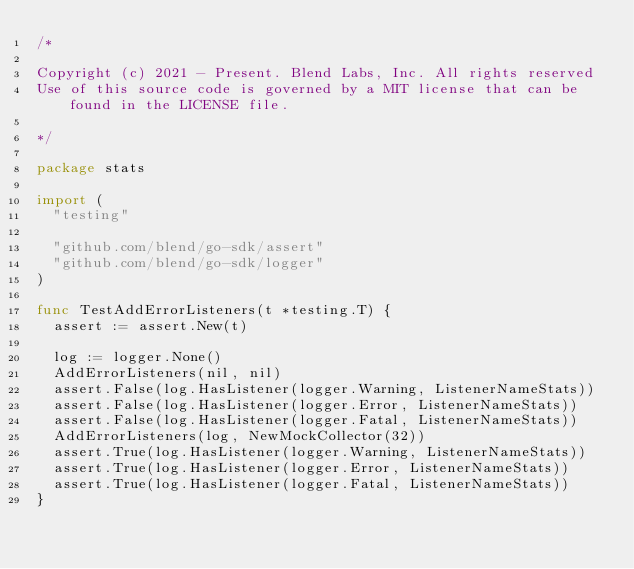Convert code to text. <code><loc_0><loc_0><loc_500><loc_500><_Go_>/*

Copyright (c) 2021 - Present. Blend Labs, Inc. All rights reserved
Use of this source code is governed by a MIT license that can be found in the LICENSE file.

*/

package stats

import (
	"testing"

	"github.com/blend/go-sdk/assert"
	"github.com/blend/go-sdk/logger"
)

func TestAddErrorListeners(t *testing.T) {
	assert := assert.New(t)

	log := logger.None()
	AddErrorListeners(nil, nil)
	assert.False(log.HasListener(logger.Warning, ListenerNameStats))
	assert.False(log.HasListener(logger.Error, ListenerNameStats))
	assert.False(log.HasListener(logger.Fatal, ListenerNameStats))
	AddErrorListeners(log, NewMockCollector(32))
	assert.True(log.HasListener(logger.Warning, ListenerNameStats))
	assert.True(log.HasListener(logger.Error, ListenerNameStats))
	assert.True(log.HasListener(logger.Fatal, ListenerNameStats))
}
</code> 